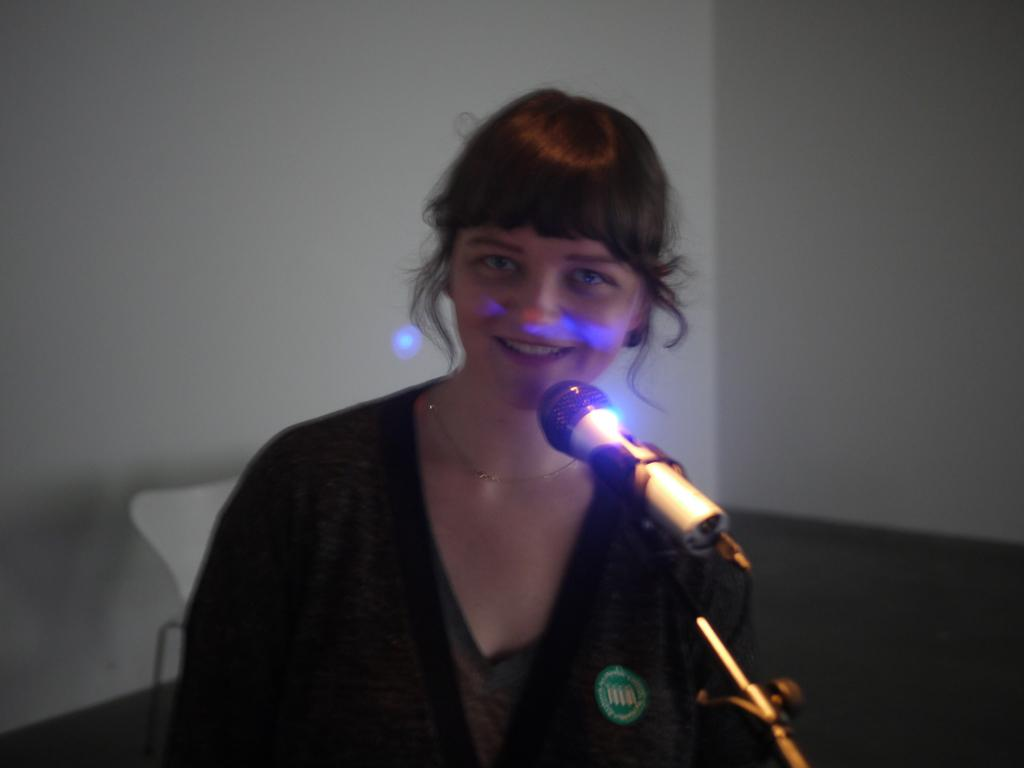Who or what is present in the image? There is a person in the image. What object is associated with the person in the image? There is a microphone in the image. What can be seen beneath the person and microphone? The ground is visible in the image. What is the background of the image composed of? There is a wall in the image. What color is the white-colored object in the image? There is a white-colored object in the image. Can you see any mice or frogs interacting with the person in the image? There are no mice or frogs present in the image. Is there a sofa visible in the image? There is no sofa present in the image. 